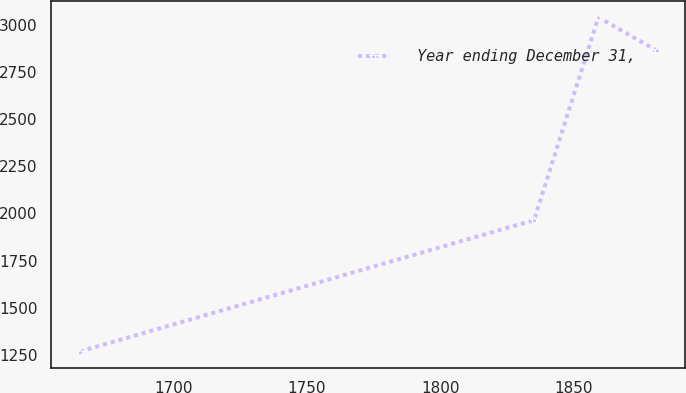Convert chart to OTSL. <chart><loc_0><loc_0><loc_500><loc_500><line_chart><ecel><fcel>Year ending December 31,<nl><fcel>1664.87<fcel>1269.19<nl><fcel>1835.21<fcel>1964.88<nl><fcel>1859.34<fcel>3038.88<nl><fcel>1881.15<fcel>2863.66<nl></chart> 